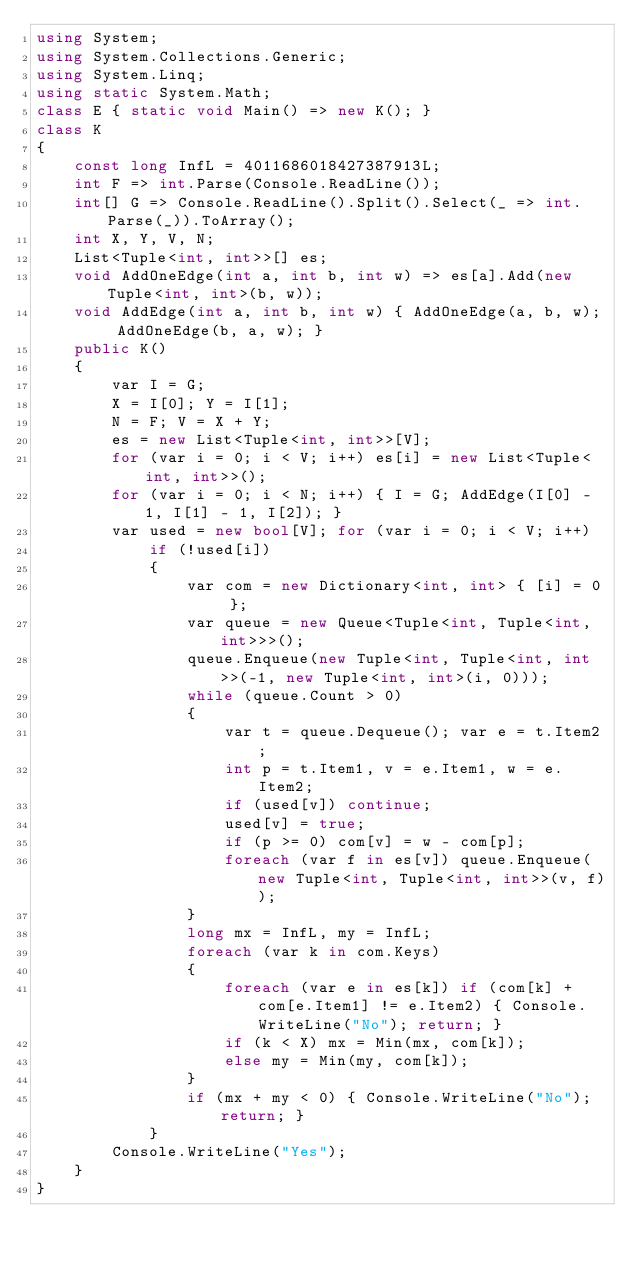Convert code to text. <code><loc_0><loc_0><loc_500><loc_500><_C#_>using System;
using System.Collections.Generic;
using System.Linq;
using static System.Math;
class E { static void Main() => new K(); }
class K
{
	const long InfL = 4011686018427387913L;
	int F => int.Parse(Console.ReadLine());
	int[] G => Console.ReadLine().Split().Select(_ => int.Parse(_)).ToArray();
	int X, Y, V, N;
	List<Tuple<int, int>>[] es;
	void AddOneEdge(int a, int b, int w) => es[a].Add(new Tuple<int, int>(b, w));
	void AddEdge(int a, int b, int w) { AddOneEdge(a, b, w); AddOneEdge(b, a, w); }
	public K()
	{
		var I = G;
		X = I[0]; Y = I[1];
		N = F; V = X + Y;
		es = new List<Tuple<int, int>>[V];
		for (var i = 0; i < V; i++) es[i] = new List<Tuple<int, int>>();
		for (var i = 0; i < N; i++) { I = G; AddEdge(I[0] - 1, I[1] - 1, I[2]); }
		var used = new bool[V]; for (var i = 0; i < V; i++)
			if (!used[i])
			{
				var com = new Dictionary<int, int> { [i] = 0 };
				var queue = new Queue<Tuple<int, Tuple<int, int>>>();
				queue.Enqueue(new Tuple<int, Tuple<int, int>>(-1, new Tuple<int, int>(i, 0)));
				while (queue.Count > 0)
				{
					var t = queue.Dequeue(); var e = t.Item2;
					int p = t.Item1, v = e.Item1, w = e.Item2;
					if (used[v]) continue;
					used[v] = true;
					if (p >= 0) com[v] = w - com[p];
					foreach (var f in es[v]) queue.Enqueue(new Tuple<int, Tuple<int, int>>(v, f));
				}
				long mx = InfL, my = InfL;
				foreach (var k in com.Keys)
				{
					foreach (var e in es[k]) if (com[k] + com[e.Item1] != e.Item2) { Console.WriteLine("No"); return; }
					if (k < X) mx = Min(mx, com[k]);
					else my = Min(my, com[k]);
				}
				if (mx + my < 0) { Console.WriteLine("No"); return; }
			}
		Console.WriteLine("Yes");
	}
}</code> 